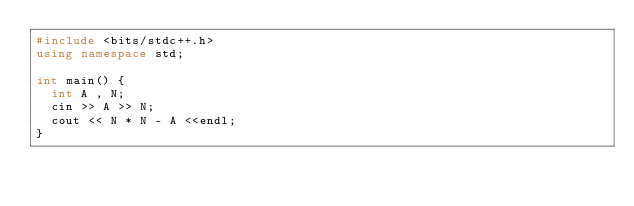Convert code to text. <code><loc_0><loc_0><loc_500><loc_500><_C++_>#include <bits/stdc++.h>
using namespace std;

int main() {
	int A , N;
	cin >> A >> N;
	cout << N * N - A <<endl;
}
</code> 